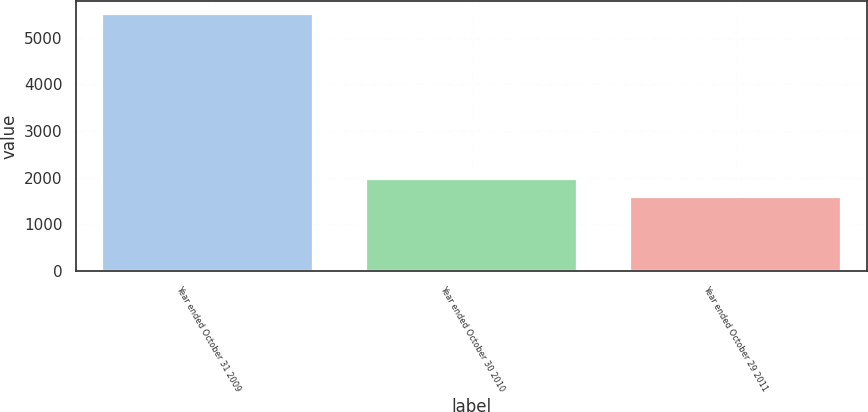<chart> <loc_0><loc_0><loc_500><loc_500><bar_chart><fcel>Year ended October 31 2009<fcel>Year ended October 30 2010<fcel>Year ended October 29 2011<nl><fcel>5501<fcel>1973<fcel>1581<nl></chart> 